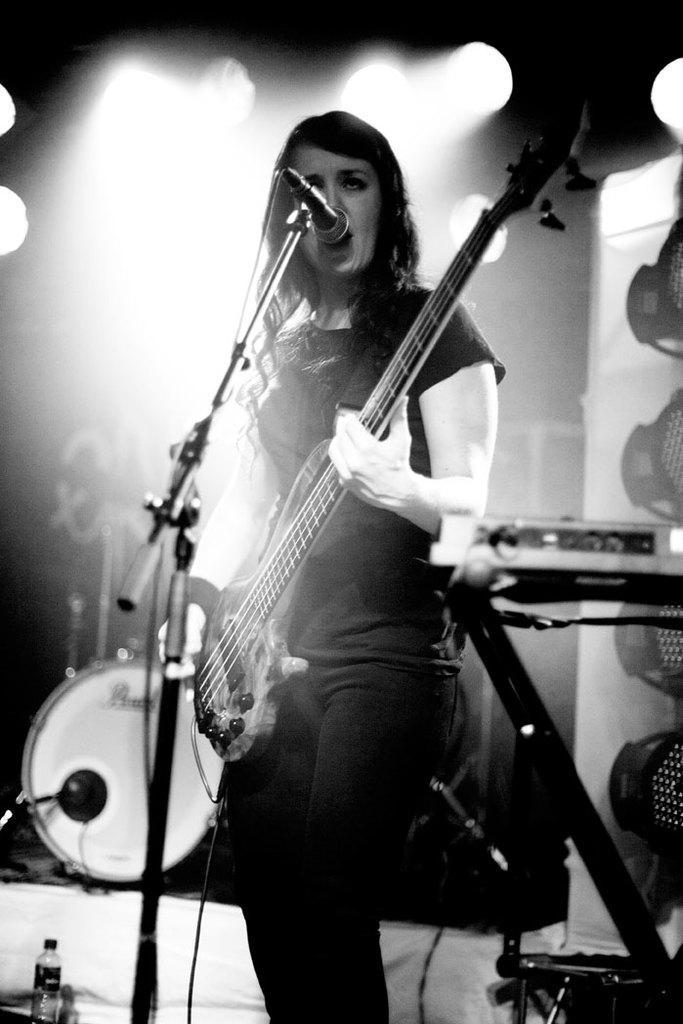Describe this image in one or two sentences. This is an edited picture. In the center of the picture there is a woman playing guitar. In the foreground there is a mic. In the center of the picture there are musical instruments like piano and drum. In the background there are lights. 